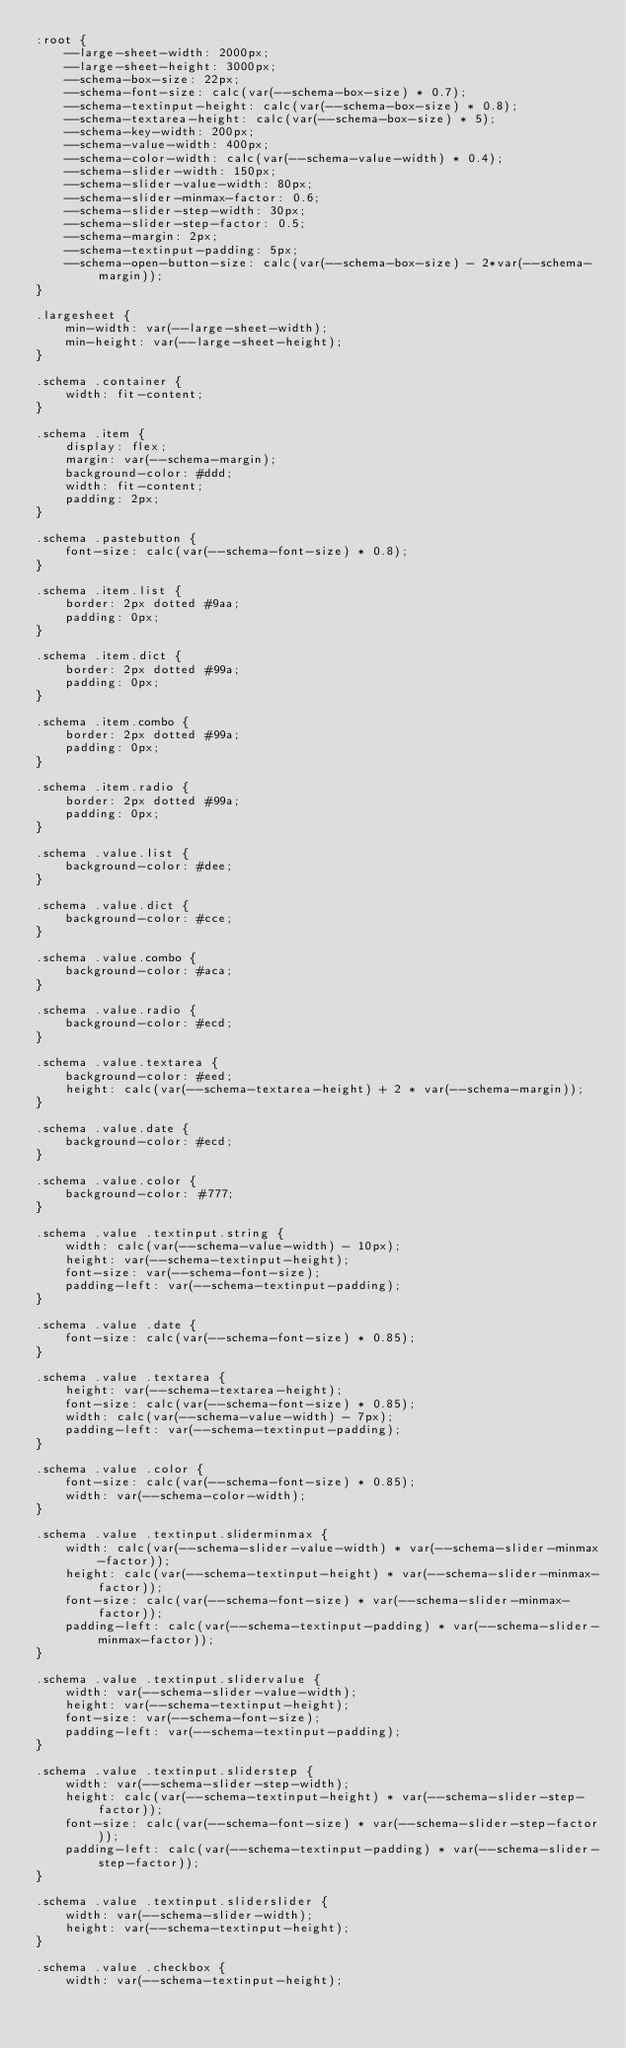<code> <loc_0><loc_0><loc_500><loc_500><_CSS_>:root {
    --large-sheet-width: 2000px;
    --large-sheet-height: 3000px;
    --schema-box-size: 22px;
    --schema-font-size: calc(var(--schema-box-size) * 0.7);
    --schema-textinput-height: calc(var(--schema-box-size) * 0.8);
    --schema-textarea-height: calc(var(--schema-box-size) * 5);
    --schema-key-width: 200px;
    --schema-value-width: 400px;
    --schema-color-width: calc(var(--schema-value-width) * 0.4);
    --schema-slider-width: 150px;
    --schema-slider-value-width: 80px;    
    --schema-slider-minmax-factor: 0.6;
    --schema-slider-step-width: 30px;    
    --schema-slider-step-factor: 0.5;
    --schema-margin: 2px;    
    --schema-textinput-padding: 5px;
    --schema-open-button-size: calc(var(--schema-box-size) - 2*var(--schema-margin));
}

.largesheet {
    min-width: var(--large-sheet-width);
    min-height: var(--large-sheet-height);
}

.schema .container {    
    width: fit-content;
}

.schema .item {
    display: flex;
    margin: var(--schema-margin);
    background-color: #ddd;    
    width: fit-content;
    padding: 2px;    
}

.schema .pastebutton {
    font-size: calc(var(--schema-font-size) * 0.8);        
}

.schema .item.list {
    border: 2px dotted #9aa;
    padding: 0px;
}

.schema .item.dict {
    border: 2px dotted #99a;
    padding: 0px;
}

.schema .item.combo {
    border: 2px dotted #99a;
    padding: 0px;
}

.schema .item.radio {
    border: 2px dotted #99a;
    padding: 0px;
}

.schema .value.list {
    background-color: #dee;
}

.schema .value.dict {
    background-color: #cce;    
}

.schema .value.combo {
    background-color: #aca;
}

.schema .value.radio {
    background-color: #ecd;    
}

.schema .value.textarea {
    background-color: #eed;    
    height: calc(var(--schema-textarea-height) + 2 * var(--schema-margin));
}

.schema .value.date {
    background-color: #ecd;
}

.schema .value.color {
    background-color: #777;
}

.schema .value .textinput.string {
    width: calc(var(--schema-value-width) - 10px);
    height: var(--schema-textinput-height);
    font-size: var(--schema-font-size);
    padding-left: var(--schema-textinput-padding);
}

.schema .value .date {    
    font-size: calc(var(--schema-font-size) * 0.85);
}

.schema .value .textarea {    
    height: var(--schema-textarea-height);
    font-size: calc(var(--schema-font-size) * 0.85);
    width: calc(var(--schema-value-width) - 7px);
    padding-left: var(--schema-textinput-padding);
}

.schema .value .color {    
    font-size: calc(var(--schema-font-size) * 0.85);
    width: var(--schema-color-width);
}

.schema .value .textinput.sliderminmax {
    width: calc(var(--schema-slider-value-width) * var(--schema-slider-minmax-factor));
    height: calc(var(--schema-textinput-height) * var(--schema-slider-minmax-factor));
    font-size: calc(var(--schema-font-size) * var(--schema-slider-minmax-factor));
    padding-left: calc(var(--schema-textinput-padding) * var(--schema-slider-minmax-factor));
}

.schema .value .textinput.slidervalue {
    width: var(--schema-slider-value-width);
    height: var(--schema-textinput-height);
    font-size: var(--schema-font-size);
    padding-left: var(--schema-textinput-padding);
}

.schema .value .textinput.sliderstep {
    width: var(--schema-slider-step-width);
    height: calc(var(--schema-textinput-height) * var(--schema-slider-step-factor));
    font-size: calc(var(--schema-font-size) * var(--schema-slider-step-factor));
    padding-left: calc(var(--schema-textinput-padding) * var(--schema-slider-step-factor));
}

.schema .value .textinput.sliderslider {
    width: var(--schema-slider-width);
    height: var(--schema-textinput-height);
}

.schema .value .checkbox {
    width: var(--schema-textinput-height);</code> 